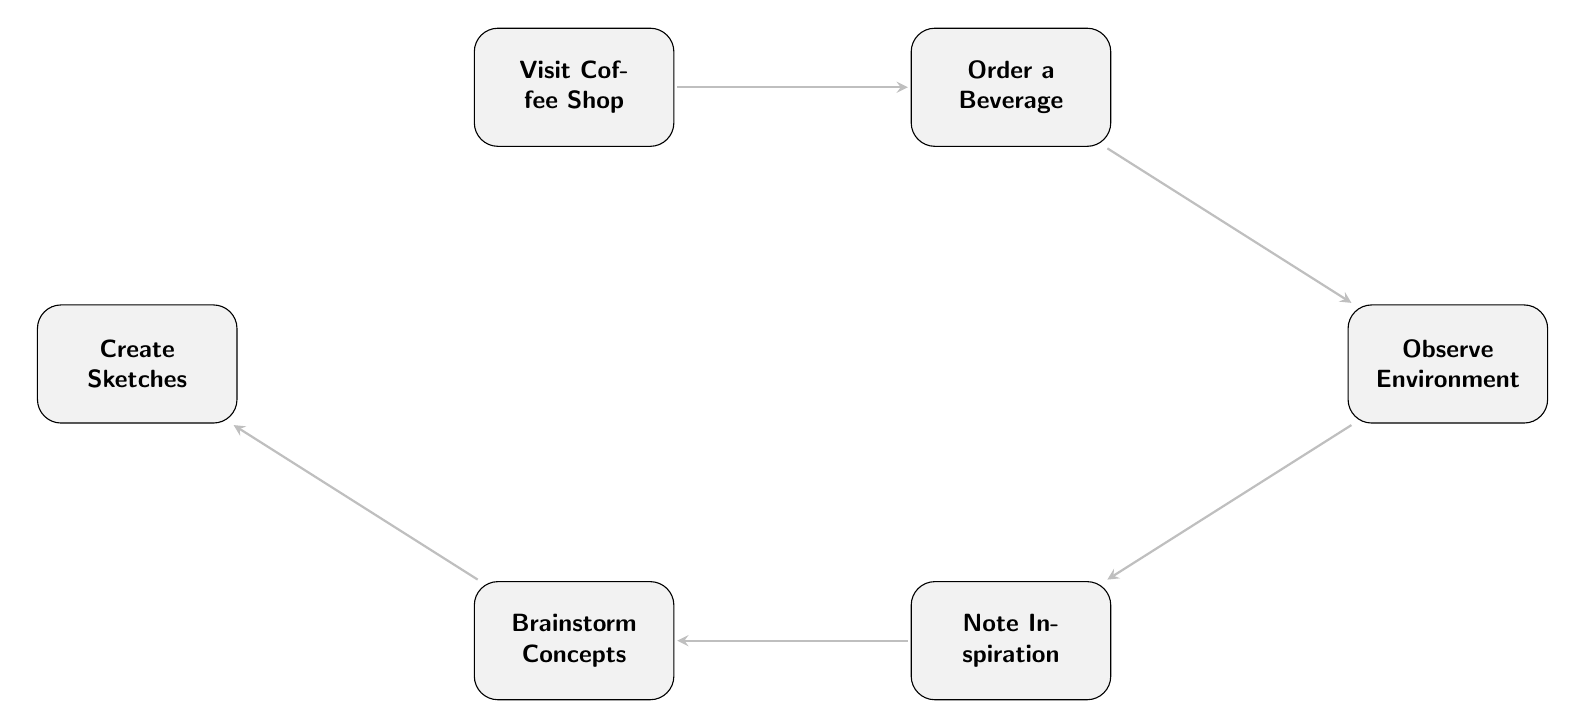What is the first step in the process? The first step in the process is represented by the node titled "Visit Coffee Shop," indicating the starting point of the journey toward fashion design inspiration.
Answer: Visit Coffee Shop How many nodes are in the diagram? The diagram contains a total of six nodes, each representing a distinct step in the flow from visiting a coffee shop to creating sketches.
Answer: 6 What follows after "Order a Beverage"? After "Order a Beverage," the next step in the flow chart is "Observe Environment," indicating that the process continues with observation while waiting for the drink.
Answer: Observe Environment What is the relationship between "Note Inspiration" and "Brainstorm Concepts"? "Note Inspiration" directly leads to "Brainstorm Concepts," meaning that the inspiration collected is essential for generating design ideas.
Answer: Transition Which node describes the process of putting ideas on paper? The node "Create Sketches" describes the action of translating brainstormed concepts into physical forms, signifying the transition from ideas to initial designs.
Answer: Create Sketches What is the last step in the process? The last step in the process is indicated by the node titled "Create Sketches," representing the completion of the flow after brainstorming.
Answer: Create Sketches How does one move from observing the environment to noting inspiration? Movement from "Observe Environment" to "Note Inspiration" occurs as observations are documented, highlighting the importance of reflection after gathering visual stimuli.
Answer: Document the inspiration What does "Note Inspiration" lead to? "Note Inspiration" leads to "Brainstorm Concepts," illustrating that documenting ideas is a prerequisite for developing fashion design concepts.
Answer: Brainstorm Concepts 